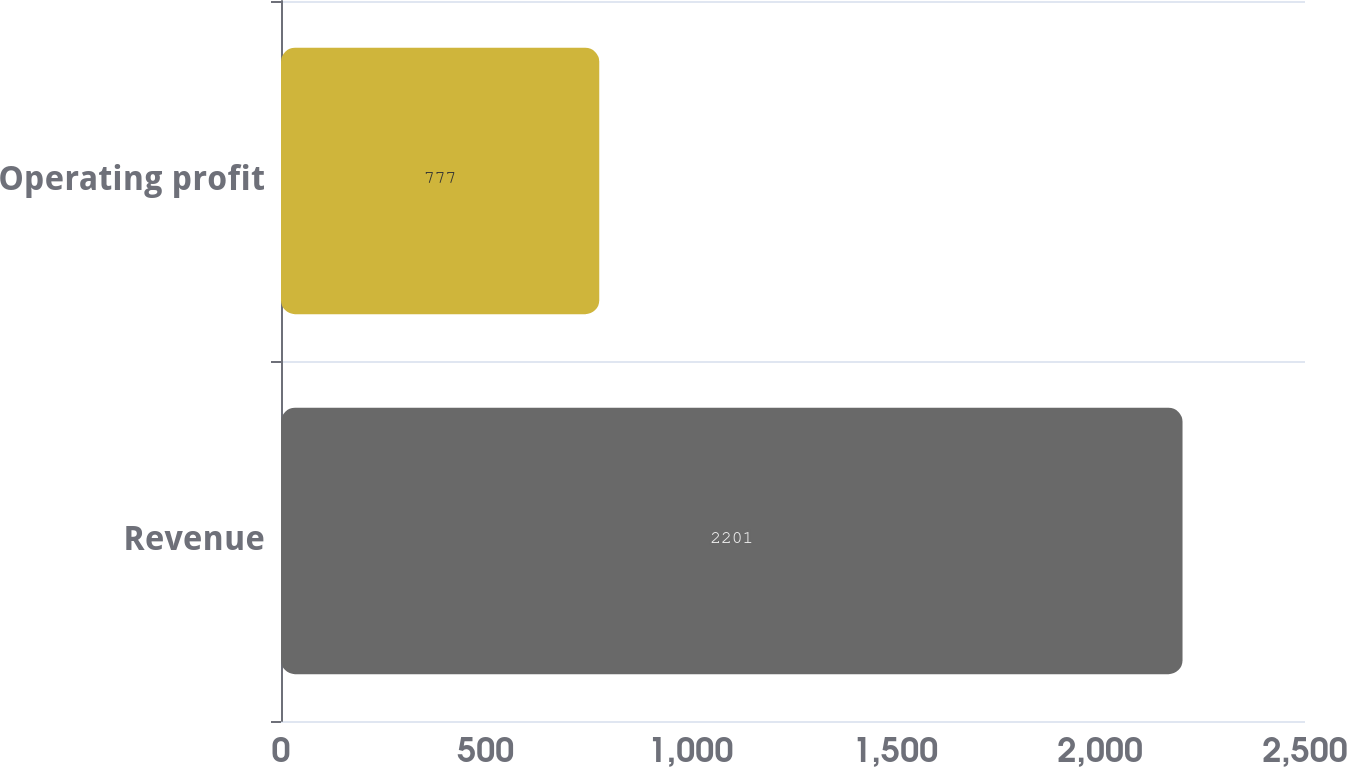Convert chart. <chart><loc_0><loc_0><loc_500><loc_500><bar_chart><fcel>Revenue<fcel>Operating profit<nl><fcel>2201<fcel>777<nl></chart> 